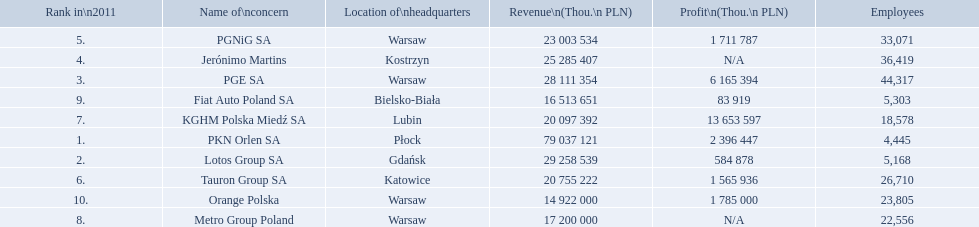What companies are listed? PKN Orlen SA, Lotos Group SA, PGE SA, Jerónimo Martins, PGNiG SA, Tauron Group SA, KGHM Polska Miedź SA, Metro Group Poland, Fiat Auto Poland SA, Orange Polska. What are the company's revenues? 79 037 121, 29 258 539, 28 111 354, 25 285 407, 23 003 534, 20 755 222, 20 097 392, 17 200 000, 16 513 651, 14 922 000. Which company has the greatest revenue? PKN Orlen SA. 